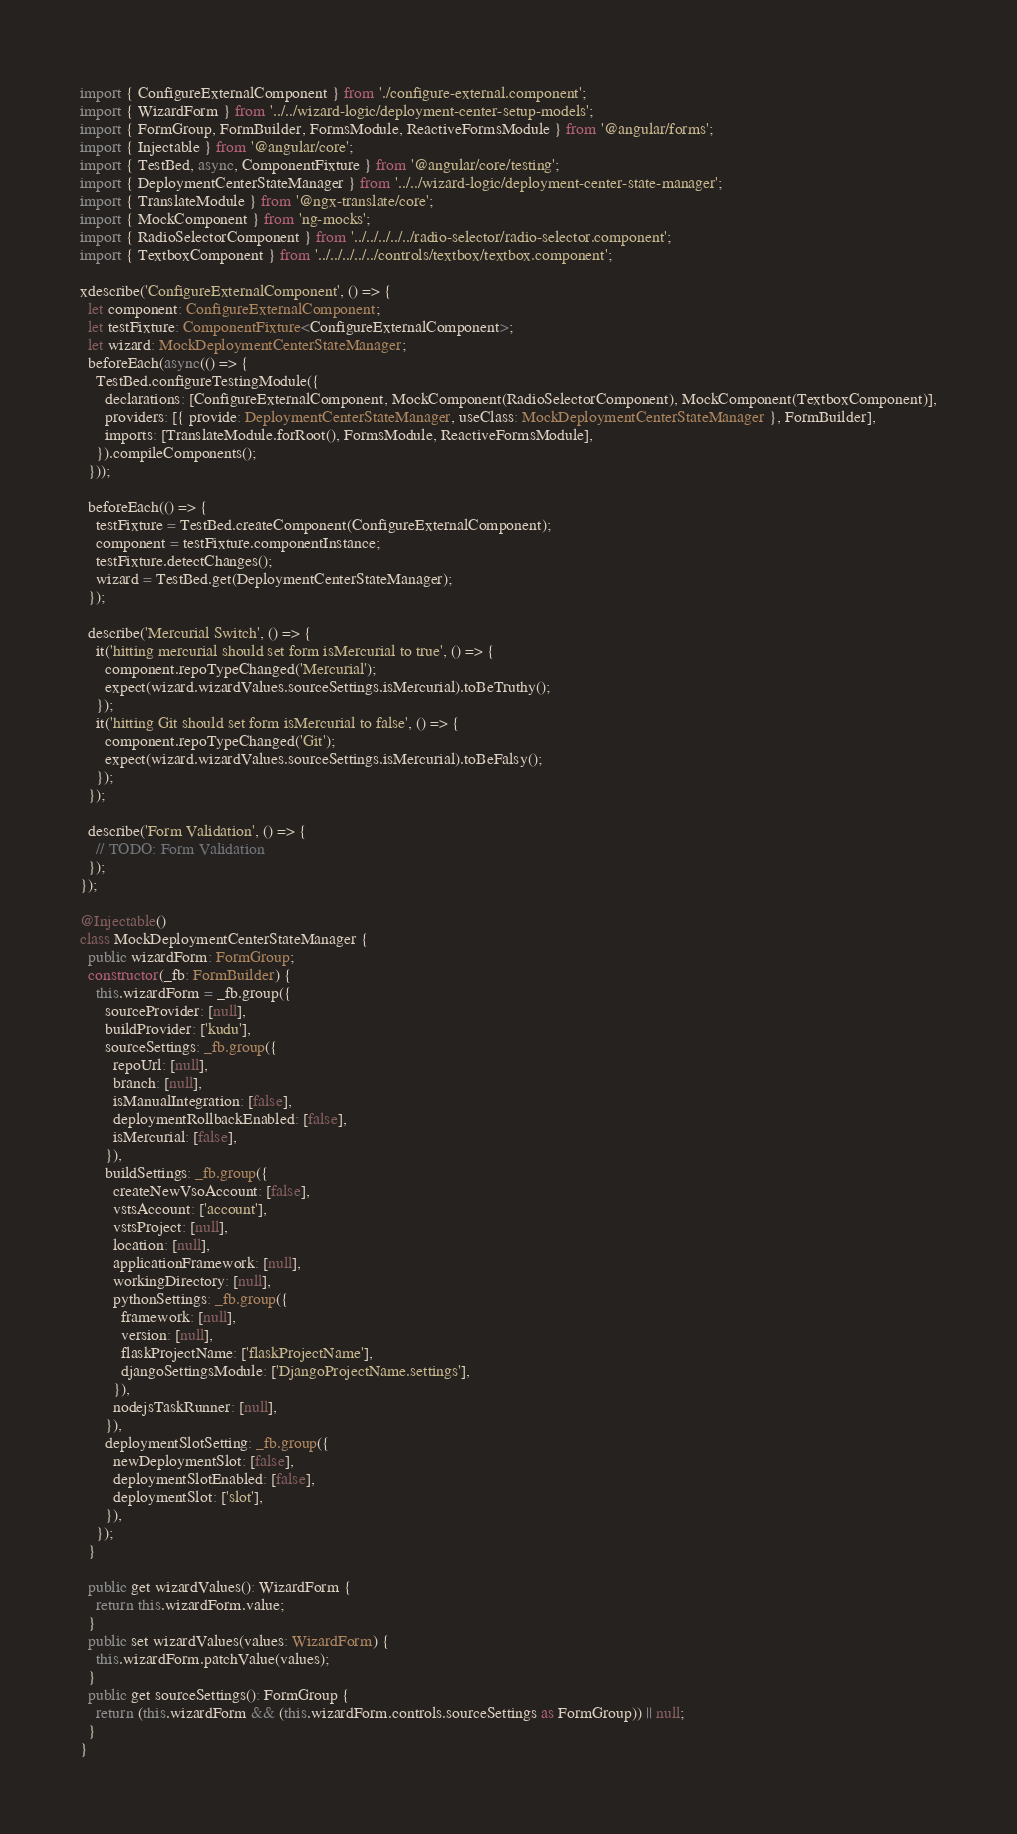<code> <loc_0><loc_0><loc_500><loc_500><_TypeScript_>import { ConfigureExternalComponent } from './configure-external.component';
import { WizardForm } from '../../wizard-logic/deployment-center-setup-models';
import { FormGroup, FormBuilder, FormsModule, ReactiveFormsModule } from '@angular/forms';
import { Injectable } from '@angular/core';
import { TestBed, async, ComponentFixture } from '@angular/core/testing';
import { DeploymentCenterStateManager } from '../../wizard-logic/deployment-center-state-manager';
import { TranslateModule } from '@ngx-translate/core';
import { MockComponent } from 'ng-mocks';
import { RadioSelectorComponent } from '../../../../../radio-selector/radio-selector.component';
import { TextboxComponent } from '../../../../../controls/textbox/textbox.component';

xdescribe('ConfigureExternalComponent', () => {
  let component: ConfigureExternalComponent;
  let testFixture: ComponentFixture<ConfigureExternalComponent>;
  let wizard: MockDeploymentCenterStateManager;
  beforeEach(async(() => {
    TestBed.configureTestingModule({
      declarations: [ConfigureExternalComponent, MockComponent(RadioSelectorComponent), MockComponent(TextboxComponent)],
      providers: [{ provide: DeploymentCenterStateManager, useClass: MockDeploymentCenterStateManager }, FormBuilder],
      imports: [TranslateModule.forRoot(), FormsModule, ReactiveFormsModule],
    }).compileComponents();
  }));

  beforeEach(() => {
    testFixture = TestBed.createComponent(ConfigureExternalComponent);
    component = testFixture.componentInstance;
    testFixture.detectChanges();
    wizard = TestBed.get(DeploymentCenterStateManager);
  });

  describe('Mercurial Switch', () => {
    it('hitting mercurial should set form isMercurial to true', () => {
      component.repoTypeChanged('Mercurial');
      expect(wizard.wizardValues.sourceSettings.isMercurial).toBeTruthy();
    });
    it('hitting Git should set form isMercurial to false', () => {
      component.repoTypeChanged('Git');
      expect(wizard.wizardValues.sourceSettings.isMercurial).toBeFalsy();
    });
  });

  describe('Form Validation', () => {
    // TODO: Form Validation
  });
});

@Injectable()
class MockDeploymentCenterStateManager {
  public wizardForm: FormGroup;
  constructor(_fb: FormBuilder) {
    this.wizardForm = _fb.group({
      sourceProvider: [null],
      buildProvider: ['kudu'],
      sourceSettings: _fb.group({
        repoUrl: [null],
        branch: [null],
        isManualIntegration: [false],
        deploymentRollbackEnabled: [false],
        isMercurial: [false],
      }),
      buildSettings: _fb.group({
        createNewVsoAccount: [false],
        vstsAccount: ['account'],
        vstsProject: [null],
        location: [null],
        applicationFramework: [null],
        workingDirectory: [null],
        pythonSettings: _fb.group({
          framework: [null],
          version: [null],
          flaskProjectName: ['flaskProjectName'],
          djangoSettingsModule: ['DjangoProjectName.settings'],
        }),
        nodejsTaskRunner: [null],
      }),
      deploymentSlotSetting: _fb.group({
        newDeploymentSlot: [false],
        deploymentSlotEnabled: [false],
        deploymentSlot: ['slot'],
      }),
    });
  }

  public get wizardValues(): WizardForm {
    return this.wizardForm.value;
  }
  public set wizardValues(values: WizardForm) {
    this.wizardForm.patchValue(values);
  }
  public get sourceSettings(): FormGroup {
    return (this.wizardForm && (this.wizardForm.controls.sourceSettings as FormGroup)) || null;
  }
}
</code> 